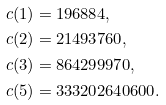<formula> <loc_0><loc_0><loc_500><loc_500>c ( 1 ) & = 1 9 6 8 8 4 , \\ c ( 2 ) & = 2 1 4 9 3 7 6 0 , \\ c ( 3 ) & = 8 6 4 2 9 9 9 7 0 , \\ c ( 5 ) & = 3 3 3 2 0 2 6 4 0 6 0 0 .</formula> 